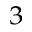Convert formula to latex. <formula><loc_0><loc_0><loc_500><loc_500>_ { 3 }</formula> 